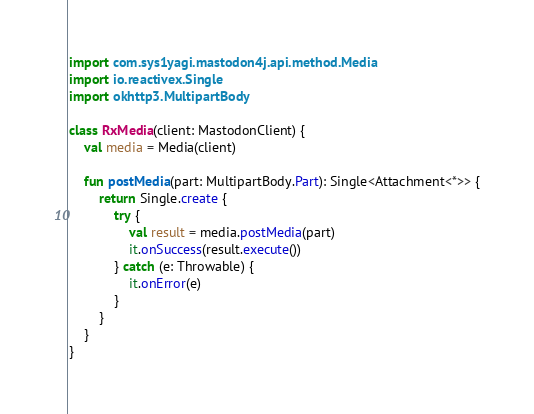Convert code to text. <code><loc_0><loc_0><loc_500><loc_500><_Kotlin_>import com.sys1yagi.mastodon4j.api.method.Media
import io.reactivex.Single
import okhttp3.MultipartBody

class RxMedia(client: MastodonClient) {
    val media = Media(client)

    fun postMedia(part: MultipartBody.Part): Single<Attachment<*>> {
        return Single.create {
            try {
                val result = media.postMedia(part)
                it.onSuccess(result.execute())
            } catch (e: Throwable) {
                it.onError(e)
            }
        }
    }
}
</code> 